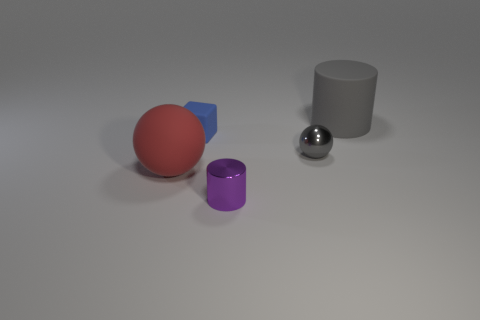Subtract all red balls. Subtract all cyan cylinders. How many balls are left? 1 Add 1 big blue rubber things. How many objects exist? 6 Subtract all spheres. How many objects are left? 3 Add 1 rubber spheres. How many rubber spheres are left? 2 Add 2 rubber cubes. How many rubber cubes exist? 3 Subtract 0 cyan spheres. How many objects are left? 5 Subtract all rubber cylinders. Subtract all big blue metal blocks. How many objects are left? 4 